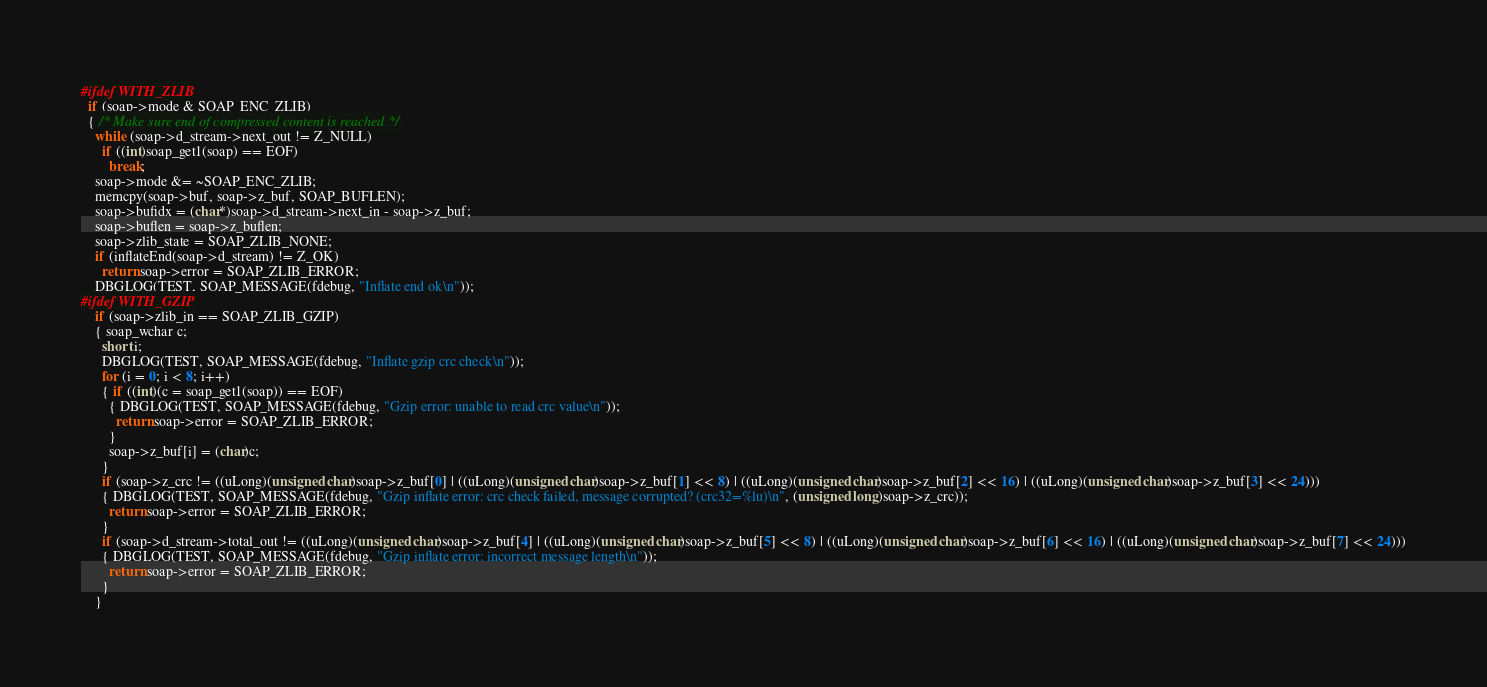Convert code to text. <code><loc_0><loc_0><loc_500><loc_500><_C++_>#ifdef WITH_ZLIB
  if (soap->mode & SOAP_ENC_ZLIB)
  { /* Make sure end of compressed content is reached */
    while (soap->d_stream->next_out != Z_NULL)
      if ((int)soap_get1(soap) == EOF)
        break;
    soap->mode &= ~SOAP_ENC_ZLIB;
    memcpy(soap->buf, soap->z_buf, SOAP_BUFLEN);
    soap->bufidx = (char*)soap->d_stream->next_in - soap->z_buf;
    soap->buflen = soap->z_buflen;
    soap->zlib_state = SOAP_ZLIB_NONE;
    if (inflateEnd(soap->d_stream) != Z_OK)
      return soap->error = SOAP_ZLIB_ERROR;
    DBGLOG(TEST, SOAP_MESSAGE(fdebug, "Inflate end ok\n"));
#ifdef WITH_GZIP
    if (soap->zlib_in == SOAP_ZLIB_GZIP)
    { soap_wchar c;
      short i;
      DBGLOG(TEST, SOAP_MESSAGE(fdebug, "Inflate gzip crc check\n"));
      for (i = 0; i < 8; i++)
      { if ((int)(c = soap_get1(soap)) == EOF)
        { DBGLOG(TEST, SOAP_MESSAGE(fdebug, "Gzip error: unable to read crc value\n"));
          return soap->error = SOAP_ZLIB_ERROR;
        }
        soap->z_buf[i] = (char)c;
      }
      if (soap->z_crc != ((uLong)(unsigned char)soap->z_buf[0] | ((uLong)(unsigned char)soap->z_buf[1] << 8) | ((uLong)(unsigned char)soap->z_buf[2] << 16) | ((uLong)(unsigned char)soap->z_buf[3] << 24)))
      { DBGLOG(TEST, SOAP_MESSAGE(fdebug, "Gzip inflate error: crc check failed, message corrupted? (crc32=%lu)\n", (unsigned long)soap->z_crc));
        return soap->error = SOAP_ZLIB_ERROR;
      }
      if (soap->d_stream->total_out != ((uLong)(unsigned char)soap->z_buf[4] | ((uLong)(unsigned char)soap->z_buf[5] << 8) | ((uLong)(unsigned char)soap->z_buf[6] << 16) | ((uLong)(unsigned char)soap->z_buf[7] << 24)))
      { DBGLOG(TEST, SOAP_MESSAGE(fdebug, "Gzip inflate error: incorrect message length\n"));
        return soap->error = SOAP_ZLIB_ERROR;
      }
    }</code> 